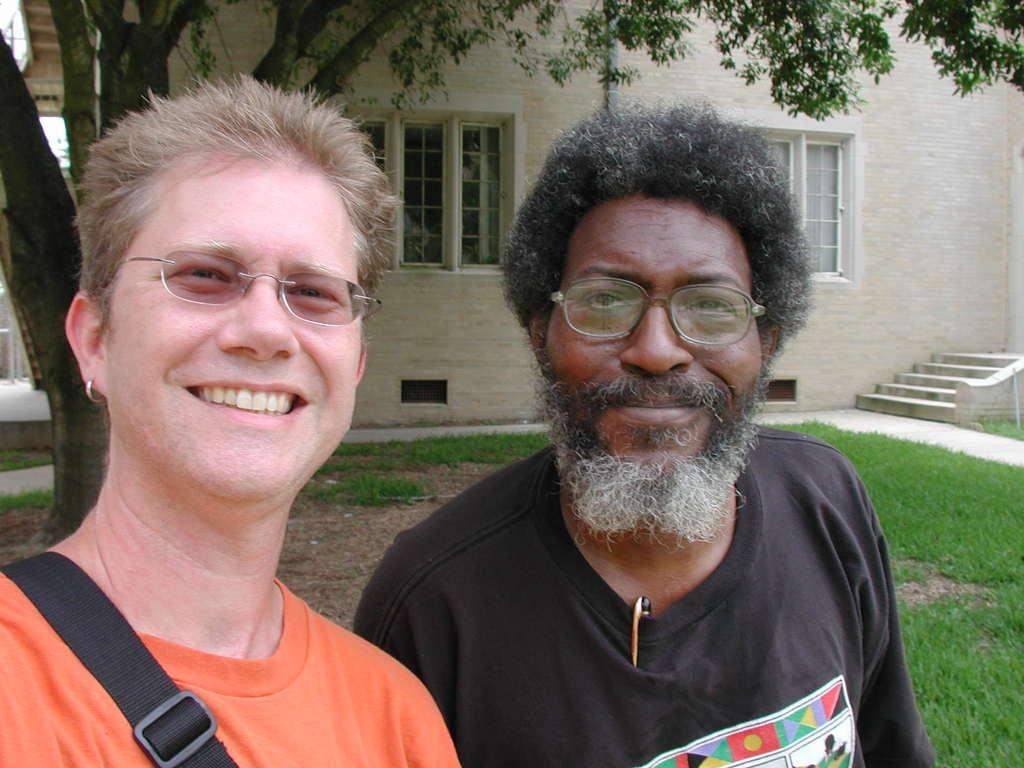How many people are in the image? There are two persons in the image. What is the facial expression of the persons in the image? The persons are standing with a smile on their face. What can be seen in the background of the image? There is a building and a tree behind the persons. How many chickens are there in the image? There are no chickens present in the image. Can you tell me how many steps are visible in the image? There is no reference to steps in the image, so it's not possible to determine how many might be visible. 